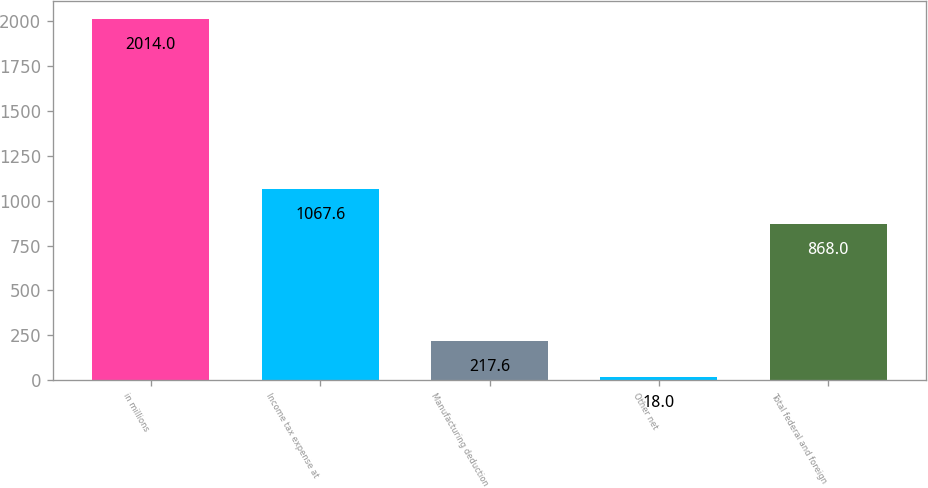<chart> <loc_0><loc_0><loc_500><loc_500><bar_chart><fcel>in millions<fcel>Income tax expense at<fcel>Manufacturing deduction<fcel>Other net<fcel>Total federal and foreign<nl><fcel>2014<fcel>1067.6<fcel>217.6<fcel>18<fcel>868<nl></chart> 